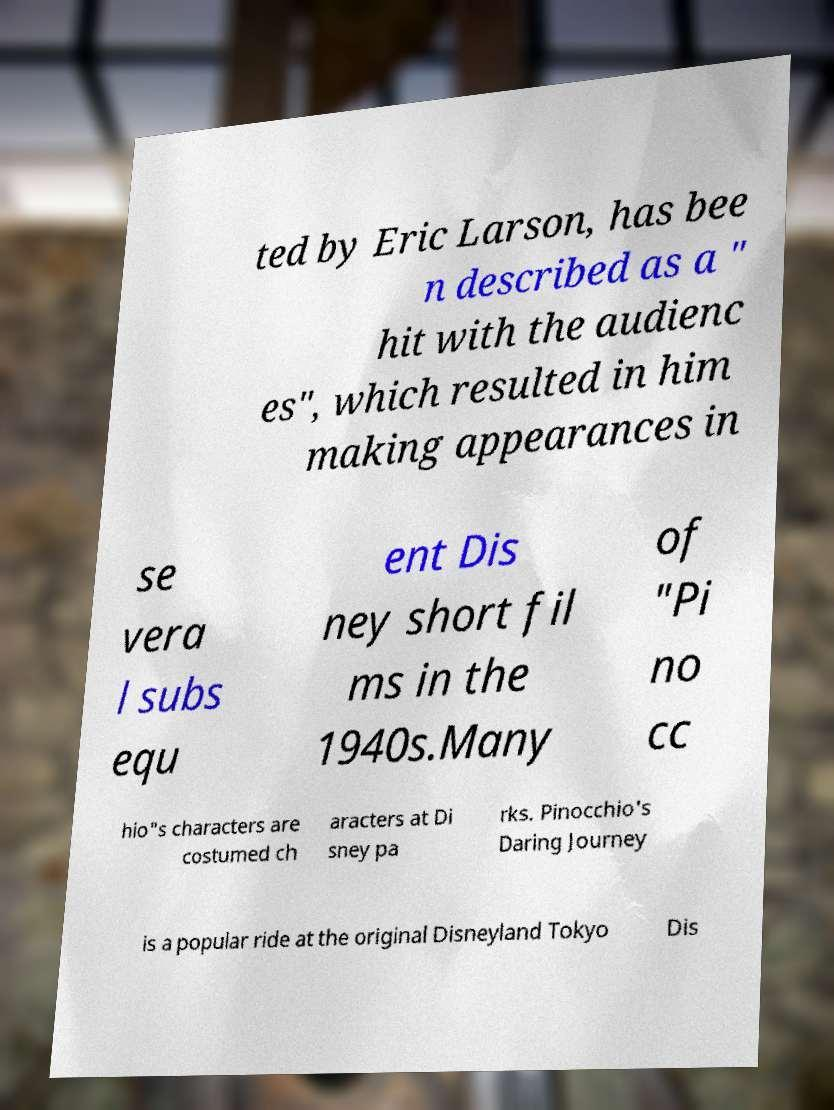Could you assist in decoding the text presented in this image and type it out clearly? ted by Eric Larson, has bee n described as a " hit with the audienc es", which resulted in him making appearances in se vera l subs equ ent Dis ney short fil ms in the 1940s.Many of "Pi no cc hio"s characters are costumed ch aracters at Di sney pa rks. Pinocchio's Daring Journey is a popular ride at the original Disneyland Tokyo Dis 